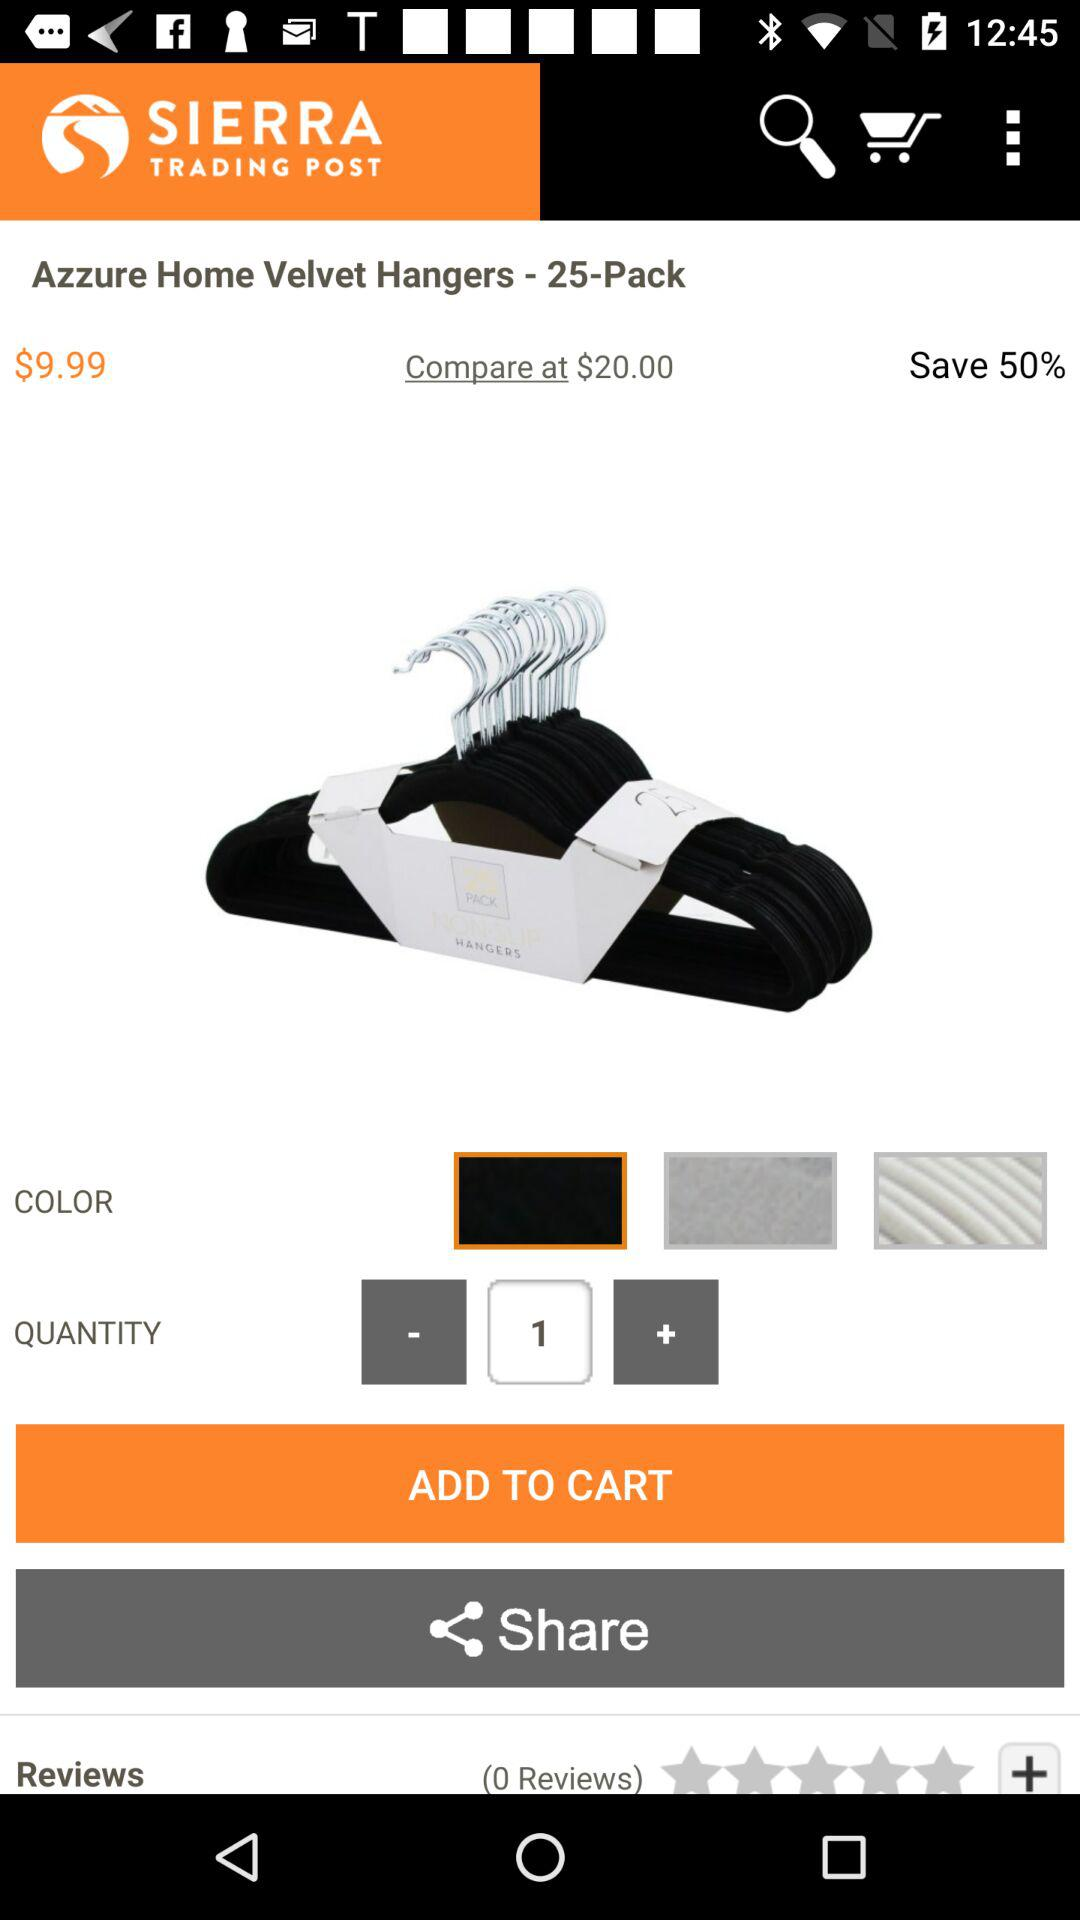How many items are in the product's package? There are 25 items in the product's package. 